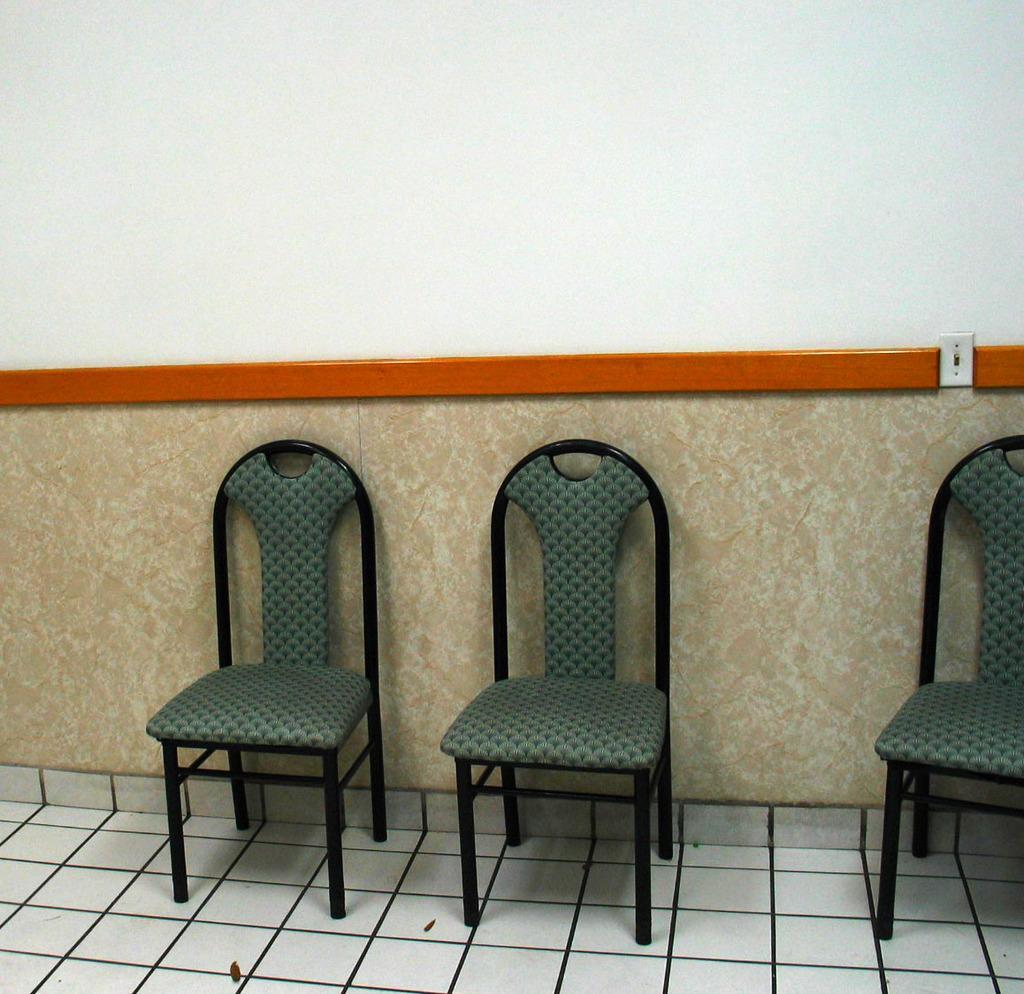Could you give a brief overview of what you see in this image? In this image I can see there are chairs on the floor. And there is a marble. And at the back there is a wall. 